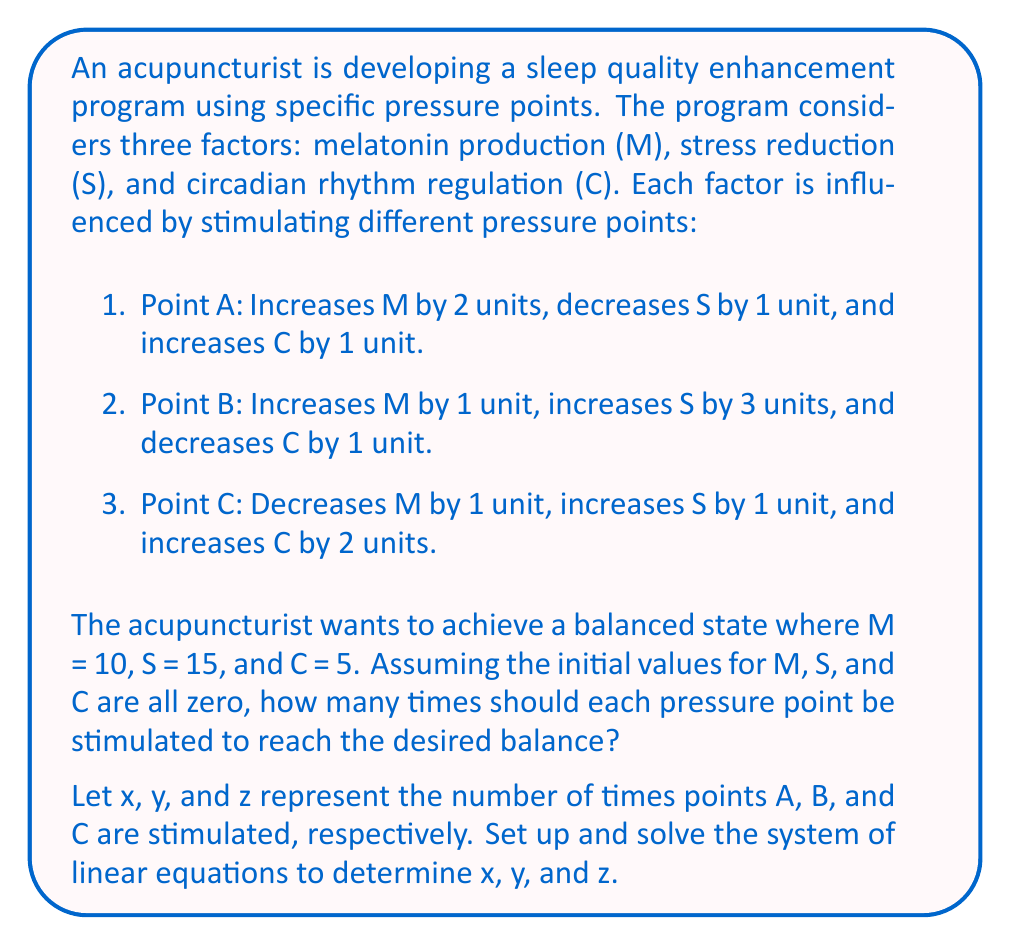Teach me how to tackle this problem. To solve this problem, we need to set up a system of linear equations based on the given information:

1. For melatonin production (M):
   $$2x + y - z = 10$$

2. For stress reduction (S):
   $$-x + 3y + z = 15$$

3. For circadian rhythm regulation (C):
   $$x - y + 2z = 5$$

Now we have a system of three equations with three unknowns:

$$\begin{cases}
2x + y - z = 10 \\
-x + 3y + z = 15 \\
x - y + 2z = 5
\end{cases}$$

To solve this system, we'll use the elimination method:

Step 1: Multiply the first equation by 2 and add it to the second equation to eliminate z:
$$\begin{aligned}
4x + 2y - 2z &= 20 \\
-x + 3y + z &= 15 \\
\hline
3x + 5y &= 35 \quad \text{(Equation 4)}
\end{aligned}$$

Step 2: Multiply the first equation by -1 and add it to the third equation to eliminate z:
$$\begin{aligned}
-2x - y + z &= -10 \\
x - y + 2z &= 5 \\
\hline
-x - 2y &= -5 \quad \text{(Equation 5)}
\end{aligned}$$

Step 3: Multiply Equation 5 by 3 and add it to Equation 4 to eliminate y:
$$\begin{aligned}
3x + 5y &= 35 \\
-3x - 6y &= -15 \\
\hline
-y &= 20 \\
y &= -20
\end{aligned}$$

Step 4: Substitute y = -20 into Equation 5 to find x:
$$\begin{aligned}
-x - 2(-20) &= -5 \\
-x + 40 &= -5 \\
-x &= -45 \\
x &= 45
\end{aligned}$$

Step 5: Substitute x = 45 and y = -20 into the first original equation to find z:
$$\begin{aligned}
2(45) + (-20) - z &= 10 \\
90 - 20 - z &= 10 \\
70 - z &= 10 \\
-z &= -60 \\
z &= 60
\end{aligned}$$

Therefore, the solution is x = 45, y = -20, and z = 60.
Answer: Point A: 45 times, Point B: 0 times, Point C: 60 times 